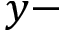Convert formula to latex. <formula><loc_0><loc_0><loc_500><loc_500>y -</formula> 